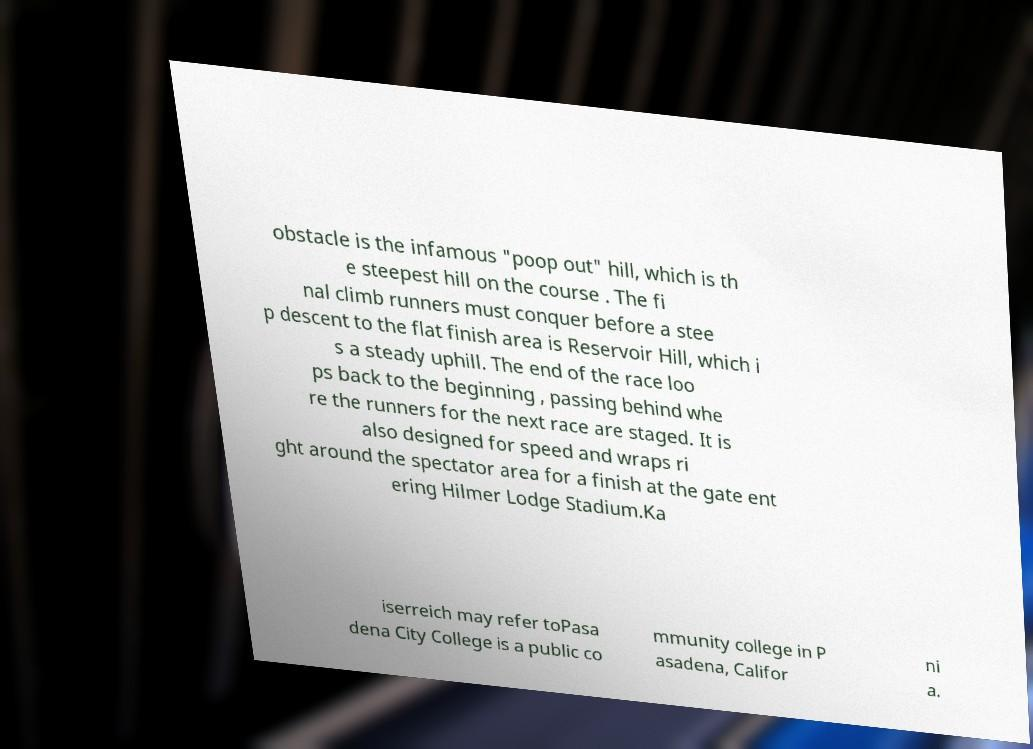What messages or text are displayed in this image? I need them in a readable, typed format. obstacle is the infamous "poop out" hill, which is th e steepest hill on the course . The fi nal climb runners must conquer before a stee p descent to the flat finish area is Reservoir Hill, which i s a steady uphill. The end of the race loo ps back to the beginning , passing behind whe re the runners for the next race are staged. It is also designed for speed and wraps ri ght around the spectator area for a finish at the gate ent ering Hilmer Lodge Stadium.Ka iserreich may refer toPasa dena City College is a public co mmunity college in P asadena, Califor ni a. 